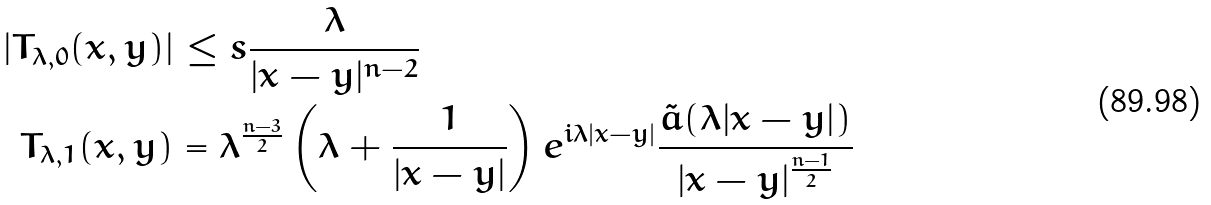<formula> <loc_0><loc_0><loc_500><loc_500>| T _ { \lambda , 0 } ( x , y ) | & \leq s \frac { \lambda } { | x - y | ^ { n - 2 } } \\ T _ { \lambda , 1 } ( x , y ) & = \lambda ^ { \frac { n - 3 } { 2 } } \left ( \lambda + \frac { 1 } { | x - y | } \right ) e ^ { i \lambda | x - y | } \frac { \tilde { a } ( \lambda | x - y | ) } { | x - y | ^ { \frac { n - 1 } { 2 } } }</formula> 